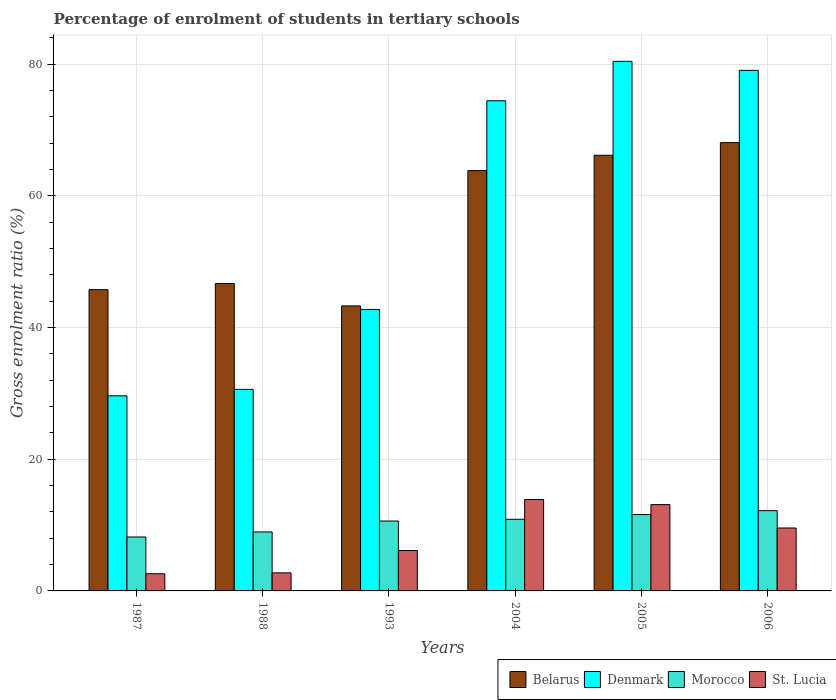How many groups of bars are there?
Offer a very short reply. 6. Are the number of bars on each tick of the X-axis equal?
Your answer should be compact. Yes. How many bars are there on the 2nd tick from the right?
Offer a terse response. 4. What is the label of the 4th group of bars from the left?
Provide a succinct answer. 2004. In how many cases, is the number of bars for a given year not equal to the number of legend labels?
Offer a very short reply. 0. What is the percentage of students enrolled in tertiary schools in Morocco in 1993?
Offer a terse response. 10.62. Across all years, what is the maximum percentage of students enrolled in tertiary schools in Belarus?
Offer a very short reply. 68.09. Across all years, what is the minimum percentage of students enrolled in tertiary schools in St. Lucia?
Keep it short and to the point. 2.61. In which year was the percentage of students enrolled in tertiary schools in Morocco maximum?
Give a very brief answer. 2006. What is the total percentage of students enrolled in tertiary schools in Denmark in the graph?
Give a very brief answer. 336.93. What is the difference between the percentage of students enrolled in tertiary schools in Belarus in 1987 and that in 2006?
Your response must be concise. -22.33. What is the difference between the percentage of students enrolled in tertiary schools in Belarus in 1987 and the percentage of students enrolled in tertiary schools in Denmark in 2004?
Your answer should be very brief. -28.69. What is the average percentage of students enrolled in tertiary schools in Denmark per year?
Keep it short and to the point. 56.15. In the year 2004, what is the difference between the percentage of students enrolled in tertiary schools in Denmark and percentage of students enrolled in tertiary schools in Belarus?
Ensure brevity in your answer.  10.61. What is the ratio of the percentage of students enrolled in tertiary schools in Denmark in 1988 to that in 2004?
Make the answer very short. 0.41. What is the difference between the highest and the second highest percentage of students enrolled in tertiary schools in Morocco?
Keep it short and to the point. 0.6. What is the difference between the highest and the lowest percentage of students enrolled in tertiary schools in Morocco?
Offer a very short reply. 4. Is it the case that in every year, the sum of the percentage of students enrolled in tertiary schools in Denmark and percentage of students enrolled in tertiary schools in St. Lucia is greater than the sum of percentage of students enrolled in tertiary schools in Morocco and percentage of students enrolled in tertiary schools in Belarus?
Provide a succinct answer. No. What does the 2nd bar from the right in 1993 represents?
Your answer should be compact. Morocco. Is it the case that in every year, the sum of the percentage of students enrolled in tertiary schools in Denmark and percentage of students enrolled in tertiary schools in Belarus is greater than the percentage of students enrolled in tertiary schools in St. Lucia?
Your response must be concise. Yes. How many bars are there?
Offer a terse response. 24. Are all the bars in the graph horizontal?
Offer a very short reply. No. How are the legend labels stacked?
Offer a very short reply. Horizontal. What is the title of the graph?
Ensure brevity in your answer.  Percentage of enrolment of students in tertiary schools. What is the label or title of the X-axis?
Offer a very short reply. Years. What is the Gross enrolment ratio (%) of Belarus in 1987?
Provide a succinct answer. 45.76. What is the Gross enrolment ratio (%) of Denmark in 1987?
Keep it short and to the point. 29.63. What is the Gross enrolment ratio (%) in Morocco in 1987?
Keep it short and to the point. 8.19. What is the Gross enrolment ratio (%) in St. Lucia in 1987?
Ensure brevity in your answer.  2.61. What is the Gross enrolment ratio (%) in Belarus in 1988?
Your answer should be very brief. 46.69. What is the Gross enrolment ratio (%) in Denmark in 1988?
Provide a short and direct response. 30.61. What is the Gross enrolment ratio (%) of Morocco in 1988?
Offer a terse response. 8.96. What is the Gross enrolment ratio (%) of St. Lucia in 1988?
Offer a very short reply. 2.74. What is the Gross enrolment ratio (%) in Belarus in 1993?
Ensure brevity in your answer.  43.29. What is the Gross enrolment ratio (%) of Denmark in 1993?
Ensure brevity in your answer.  42.75. What is the Gross enrolment ratio (%) in Morocco in 1993?
Ensure brevity in your answer.  10.62. What is the Gross enrolment ratio (%) in St. Lucia in 1993?
Your answer should be compact. 6.13. What is the Gross enrolment ratio (%) in Belarus in 2004?
Your response must be concise. 63.84. What is the Gross enrolment ratio (%) of Denmark in 2004?
Provide a succinct answer. 74.44. What is the Gross enrolment ratio (%) of Morocco in 2004?
Offer a very short reply. 10.88. What is the Gross enrolment ratio (%) in St. Lucia in 2004?
Offer a terse response. 13.88. What is the Gross enrolment ratio (%) of Belarus in 2005?
Provide a short and direct response. 66.17. What is the Gross enrolment ratio (%) of Denmark in 2005?
Your answer should be compact. 80.43. What is the Gross enrolment ratio (%) of Morocco in 2005?
Keep it short and to the point. 11.6. What is the Gross enrolment ratio (%) in St. Lucia in 2005?
Provide a short and direct response. 13.11. What is the Gross enrolment ratio (%) of Belarus in 2006?
Keep it short and to the point. 68.09. What is the Gross enrolment ratio (%) of Denmark in 2006?
Offer a terse response. 79.06. What is the Gross enrolment ratio (%) of Morocco in 2006?
Your answer should be very brief. 12.19. What is the Gross enrolment ratio (%) in St. Lucia in 2006?
Offer a terse response. 9.56. Across all years, what is the maximum Gross enrolment ratio (%) of Belarus?
Your response must be concise. 68.09. Across all years, what is the maximum Gross enrolment ratio (%) of Denmark?
Your response must be concise. 80.43. Across all years, what is the maximum Gross enrolment ratio (%) of Morocco?
Offer a terse response. 12.19. Across all years, what is the maximum Gross enrolment ratio (%) in St. Lucia?
Provide a succinct answer. 13.88. Across all years, what is the minimum Gross enrolment ratio (%) of Belarus?
Ensure brevity in your answer.  43.29. Across all years, what is the minimum Gross enrolment ratio (%) in Denmark?
Keep it short and to the point. 29.63. Across all years, what is the minimum Gross enrolment ratio (%) in Morocco?
Provide a short and direct response. 8.19. Across all years, what is the minimum Gross enrolment ratio (%) in St. Lucia?
Your answer should be very brief. 2.61. What is the total Gross enrolment ratio (%) in Belarus in the graph?
Your answer should be compact. 333.83. What is the total Gross enrolment ratio (%) in Denmark in the graph?
Offer a very short reply. 336.93. What is the total Gross enrolment ratio (%) of Morocco in the graph?
Provide a succinct answer. 62.44. What is the total Gross enrolment ratio (%) in St. Lucia in the graph?
Provide a succinct answer. 48.04. What is the difference between the Gross enrolment ratio (%) of Belarus in 1987 and that in 1988?
Offer a very short reply. -0.94. What is the difference between the Gross enrolment ratio (%) in Denmark in 1987 and that in 1988?
Ensure brevity in your answer.  -0.98. What is the difference between the Gross enrolment ratio (%) in Morocco in 1987 and that in 1988?
Offer a very short reply. -0.77. What is the difference between the Gross enrolment ratio (%) in St. Lucia in 1987 and that in 1988?
Your answer should be compact. -0.13. What is the difference between the Gross enrolment ratio (%) in Belarus in 1987 and that in 1993?
Your answer should be compact. 2.47. What is the difference between the Gross enrolment ratio (%) of Denmark in 1987 and that in 1993?
Your answer should be compact. -13.12. What is the difference between the Gross enrolment ratio (%) of Morocco in 1987 and that in 1993?
Your response must be concise. -2.43. What is the difference between the Gross enrolment ratio (%) in St. Lucia in 1987 and that in 1993?
Provide a succinct answer. -3.52. What is the difference between the Gross enrolment ratio (%) of Belarus in 1987 and that in 2004?
Offer a terse response. -18.08. What is the difference between the Gross enrolment ratio (%) of Denmark in 1987 and that in 2004?
Offer a terse response. -44.81. What is the difference between the Gross enrolment ratio (%) in Morocco in 1987 and that in 2004?
Offer a terse response. -2.69. What is the difference between the Gross enrolment ratio (%) of St. Lucia in 1987 and that in 2004?
Make the answer very short. -11.27. What is the difference between the Gross enrolment ratio (%) in Belarus in 1987 and that in 2005?
Your answer should be compact. -20.41. What is the difference between the Gross enrolment ratio (%) of Denmark in 1987 and that in 2005?
Provide a succinct answer. -50.8. What is the difference between the Gross enrolment ratio (%) of Morocco in 1987 and that in 2005?
Ensure brevity in your answer.  -3.41. What is the difference between the Gross enrolment ratio (%) in St. Lucia in 1987 and that in 2005?
Your response must be concise. -10.5. What is the difference between the Gross enrolment ratio (%) of Belarus in 1987 and that in 2006?
Provide a short and direct response. -22.33. What is the difference between the Gross enrolment ratio (%) in Denmark in 1987 and that in 2006?
Provide a short and direct response. -49.43. What is the difference between the Gross enrolment ratio (%) of Morocco in 1987 and that in 2006?
Offer a very short reply. -4. What is the difference between the Gross enrolment ratio (%) of St. Lucia in 1987 and that in 2006?
Make the answer very short. -6.95. What is the difference between the Gross enrolment ratio (%) of Belarus in 1988 and that in 1993?
Provide a succinct answer. 3.41. What is the difference between the Gross enrolment ratio (%) in Denmark in 1988 and that in 1993?
Offer a terse response. -12.14. What is the difference between the Gross enrolment ratio (%) in Morocco in 1988 and that in 1993?
Give a very brief answer. -1.66. What is the difference between the Gross enrolment ratio (%) of St. Lucia in 1988 and that in 1993?
Offer a very short reply. -3.39. What is the difference between the Gross enrolment ratio (%) in Belarus in 1988 and that in 2004?
Your answer should be very brief. -17.14. What is the difference between the Gross enrolment ratio (%) of Denmark in 1988 and that in 2004?
Offer a terse response. -43.83. What is the difference between the Gross enrolment ratio (%) of Morocco in 1988 and that in 2004?
Give a very brief answer. -1.92. What is the difference between the Gross enrolment ratio (%) of St. Lucia in 1988 and that in 2004?
Keep it short and to the point. -11.14. What is the difference between the Gross enrolment ratio (%) of Belarus in 1988 and that in 2005?
Ensure brevity in your answer.  -19.48. What is the difference between the Gross enrolment ratio (%) of Denmark in 1988 and that in 2005?
Offer a very short reply. -49.82. What is the difference between the Gross enrolment ratio (%) in Morocco in 1988 and that in 2005?
Your response must be concise. -2.64. What is the difference between the Gross enrolment ratio (%) in St. Lucia in 1988 and that in 2005?
Provide a succinct answer. -10.36. What is the difference between the Gross enrolment ratio (%) in Belarus in 1988 and that in 2006?
Your answer should be compact. -21.39. What is the difference between the Gross enrolment ratio (%) in Denmark in 1988 and that in 2006?
Provide a short and direct response. -48.45. What is the difference between the Gross enrolment ratio (%) of Morocco in 1988 and that in 2006?
Make the answer very short. -3.24. What is the difference between the Gross enrolment ratio (%) in St. Lucia in 1988 and that in 2006?
Keep it short and to the point. -6.81. What is the difference between the Gross enrolment ratio (%) of Belarus in 1993 and that in 2004?
Make the answer very short. -20.55. What is the difference between the Gross enrolment ratio (%) of Denmark in 1993 and that in 2004?
Keep it short and to the point. -31.69. What is the difference between the Gross enrolment ratio (%) of Morocco in 1993 and that in 2004?
Your answer should be compact. -0.26. What is the difference between the Gross enrolment ratio (%) in St. Lucia in 1993 and that in 2004?
Offer a very short reply. -7.75. What is the difference between the Gross enrolment ratio (%) in Belarus in 1993 and that in 2005?
Your response must be concise. -22.88. What is the difference between the Gross enrolment ratio (%) in Denmark in 1993 and that in 2005?
Provide a short and direct response. -37.68. What is the difference between the Gross enrolment ratio (%) of Morocco in 1993 and that in 2005?
Ensure brevity in your answer.  -0.98. What is the difference between the Gross enrolment ratio (%) in St. Lucia in 1993 and that in 2005?
Provide a succinct answer. -6.97. What is the difference between the Gross enrolment ratio (%) of Belarus in 1993 and that in 2006?
Your answer should be compact. -24.8. What is the difference between the Gross enrolment ratio (%) in Denmark in 1993 and that in 2006?
Provide a short and direct response. -36.32. What is the difference between the Gross enrolment ratio (%) in Morocco in 1993 and that in 2006?
Your answer should be very brief. -1.58. What is the difference between the Gross enrolment ratio (%) in St. Lucia in 1993 and that in 2006?
Give a very brief answer. -3.42. What is the difference between the Gross enrolment ratio (%) of Belarus in 2004 and that in 2005?
Your answer should be compact. -2.33. What is the difference between the Gross enrolment ratio (%) in Denmark in 2004 and that in 2005?
Keep it short and to the point. -5.99. What is the difference between the Gross enrolment ratio (%) of Morocco in 2004 and that in 2005?
Offer a very short reply. -0.72. What is the difference between the Gross enrolment ratio (%) in St. Lucia in 2004 and that in 2005?
Ensure brevity in your answer.  0.78. What is the difference between the Gross enrolment ratio (%) of Belarus in 2004 and that in 2006?
Provide a short and direct response. -4.25. What is the difference between the Gross enrolment ratio (%) in Denmark in 2004 and that in 2006?
Give a very brief answer. -4.62. What is the difference between the Gross enrolment ratio (%) of Morocco in 2004 and that in 2006?
Provide a succinct answer. -1.31. What is the difference between the Gross enrolment ratio (%) of St. Lucia in 2004 and that in 2006?
Provide a short and direct response. 4.32. What is the difference between the Gross enrolment ratio (%) of Belarus in 2005 and that in 2006?
Your answer should be very brief. -1.92. What is the difference between the Gross enrolment ratio (%) of Denmark in 2005 and that in 2006?
Provide a succinct answer. 1.36. What is the difference between the Gross enrolment ratio (%) of Morocco in 2005 and that in 2006?
Your answer should be very brief. -0.6. What is the difference between the Gross enrolment ratio (%) in St. Lucia in 2005 and that in 2006?
Give a very brief answer. 3.55. What is the difference between the Gross enrolment ratio (%) of Belarus in 1987 and the Gross enrolment ratio (%) of Denmark in 1988?
Offer a very short reply. 15.14. What is the difference between the Gross enrolment ratio (%) of Belarus in 1987 and the Gross enrolment ratio (%) of Morocco in 1988?
Keep it short and to the point. 36.8. What is the difference between the Gross enrolment ratio (%) of Belarus in 1987 and the Gross enrolment ratio (%) of St. Lucia in 1988?
Offer a very short reply. 43.01. What is the difference between the Gross enrolment ratio (%) in Denmark in 1987 and the Gross enrolment ratio (%) in Morocco in 1988?
Provide a short and direct response. 20.67. What is the difference between the Gross enrolment ratio (%) of Denmark in 1987 and the Gross enrolment ratio (%) of St. Lucia in 1988?
Provide a short and direct response. 26.89. What is the difference between the Gross enrolment ratio (%) of Morocco in 1987 and the Gross enrolment ratio (%) of St. Lucia in 1988?
Offer a terse response. 5.45. What is the difference between the Gross enrolment ratio (%) of Belarus in 1987 and the Gross enrolment ratio (%) of Denmark in 1993?
Provide a succinct answer. 3.01. What is the difference between the Gross enrolment ratio (%) in Belarus in 1987 and the Gross enrolment ratio (%) in Morocco in 1993?
Your answer should be very brief. 35.14. What is the difference between the Gross enrolment ratio (%) in Belarus in 1987 and the Gross enrolment ratio (%) in St. Lucia in 1993?
Provide a short and direct response. 39.62. What is the difference between the Gross enrolment ratio (%) in Denmark in 1987 and the Gross enrolment ratio (%) in Morocco in 1993?
Your answer should be very brief. 19.02. What is the difference between the Gross enrolment ratio (%) of Denmark in 1987 and the Gross enrolment ratio (%) of St. Lucia in 1993?
Offer a very short reply. 23.5. What is the difference between the Gross enrolment ratio (%) of Morocco in 1987 and the Gross enrolment ratio (%) of St. Lucia in 1993?
Your answer should be compact. 2.06. What is the difference between the Gross enrolment ratio (%) of Belarus in 1987 and the Gross enrolment ratio (%) of Denmark in 2004?
Make the answer very short. -28.69. What is the difference between the Gross enrolment ratio (%) of Belarus in 1987 and the Gross enrolment ratio (%) of Morocco in 2004?
Keep it short and to the point. 34.88. What is the difference between the Gross enrolment ratio (%) in Belarus in 1987 and the Gross enrolment ratio (%) in St. Lucia in 2004?
Offer a terse response. 31.87. What is the difference between the Gross enrolment ratio (%) in Denmark in 1987 and the Gross enrolment ratio (%) in Morocco in 2004?
Your response must be concise. 18.75. What is the difference between the Gross enrolment ratio (%) in Denmark in 1987 and the Gross enrolment ratio (%) in St. Lucia in 2004?
Ensure brevity in your answer.  15.75. What is the difference between the Gross enrolment ratio (%) of Morocco in 1987 and the Gross enrolment ratio (%) of St. Lucia in 2004?
Ensure brevity in your answer.  -5.69. What is the difference between the Gross enrolment ratio (%) of Belarus in 1987 and the Gross enrolment ratio (%) of Denmark in 2005?
Provide a succinct answer. -34.67. What is the difference between the Gross enrolment ratio (%) in Belarus in 1987 and the Gross enrolment ratio (%) in Morocco in 2005?
Your answer should be very brief. 34.16. What is the difference between the Gross enrolment ratio (%) in Belarus in 1987 and the Gross enrolment ratio (%) in St. Lucia in 2005?
Your answer should be very brief. 32.65. What is the difference between the Gross enrolment ratio (%) of Denmark in 1987 and the Gross enrolment ratio (%) of Morocco in 2005?
Keep it short and to the point. 18.03. What is the difference between the Gross enrolment ratio (%) of Denmark in 1987 and the Gross enrolment ratio (%) of St. Lucia in 2005?
Offer a very short reply. 16.52. What is the difference between the Gross enrolment ratio (%) of Morocco in 1987 and the Gross enrolment ratio (%) of St. Lucia in 2005?
Your response must be concise. -4.92. What is the difference between the Gross enrolment ratio (%) in Belarus in 1987 and the Gross enrolment ratio (%) in Denmark in 2006?
Provide a succinct answer. -33.31. What is the difference between the Gross enrolment ratio (%) of Belarus in 1987 and the Gross enrolment ratio (%) of Morocco in 2006?
Your response must be concise. 33.56. What is the difference between the Gross enrolment ratio (%) in Belarus in 1987 and the Gross enrolment ratio (%) in St. Lucia in 2006?
Ensure brevity in your answer.  36.2. What is the difference between the Gross enrolment ratio (%) of Denmark in 1987 and the Gross enrolment ratio (%) of Morocco in 2006?
Offer a very short reply. 17.44. What is the difference between the Gross enrolment ratio (%) of Denmark in 1987 and the Gross enrolment ratio (%) of St. Lucia in 2006?
Ensure brevity in your answer.  20.07. What is the difference between the Gross enrolment ratio (%) in Morocco in 1987 and the Gross enrolment ratio (%) in St. Lucia in 2006?
Give a very brief answer. -1.37. What is the difference between the Gross enrolment ratio (%) of Belarus in 1988 and the Gross enrolment ratio (%) of Denmark in 1993?
Provide a short and direct response. 3.95. What is the difference between the Gross enrolment ratio (%) in Belarus in 1988 and the Gross enrolment ratio (%) in Morocco in 1993?
Your answer should be compact. 36.08. What is the difference between the Gross enrolment ratio (%) in Belarus in 1988 and the Gross enrolment ratio (%) in St. Lucia in 1993?
Your answer should be very brief. 40.56. What is the difference between the Gross enrolment ratio (%) in Denmark in 1988 and the Gross enrolment ratio (%) in Morocco in 1993?
Your answer should be very brief. 20. What is the difference between the Gross enrolment ratio (%) of Denmark in 1988 and the Gross enrolment ratio (%) of St. Lucia in 1993?
Offer a very short reply. 24.48. What is the difference between the Gross enrolment ratio (%) in Morocco in 1988 and the Gross enrolment ratio (%) in St. Lucia in 1993?
Provide a succinct answer. 2.82. What is the difference between the Gross enrolment ratio (%) of Belarus in 1988 and the Gross enrolment ratio (%) of Denmark in 2004?
Ensure brevity in your answer.  -27.75. What is the difference between the Gross enrolment ratio (%) of Belarus in 1988 and the Gross enrolment ratio (%) of Morocco in 2004?
Provide a succinct answer. 35.81. What is the difference between the Gross enrolment ratio (%) in Belarus in 1988 and the Gross enrolment ratio (%) in St. Lucia in 2004?
Ensure brevity in your answer.  32.81. What is the difference between the Gross enrolment ratio (%) of Denmark in 1988 and the Gross enrolment ratio (%) of Morocco in 2004?
Give a very brief answer. 19.73. What is the difference between the Gross enrolment ratio (%) in Denmark in 1988 and the Gross enrolment ratio (%) in St. Lucia in 2004?
Your answer should be very brief. 16.73. What is the difference between the Gross enrolment ratio (%) in Morocco in 1988 and the Gross enrolment ratio (%) in St. Lucia in 2004?
Provide a short and direct response. -4.93. What is the difference between the Gross enrolment ratio (%) in Belarus in 1988 and the Gross enrolment ratio (%) in Denmark in 2005?
Your answer should be compact. -33.74. What is the difference between the Gross enrolment ratio (%) of Belarus in 1988 and the Gross enrolment ratio (%) of Morocco in 2005?
Keep it short and to the point. 35.09. What is the difference between the Gross enrolment ratio (%) of Belarus in 1988 and the Gross enrolment ratio (%) of St. Lucia in 2005?
Your answer should be very brief. 33.59. What is the difference between the Gross enrolment ratio (%) in Denmark in 1988 and the Gross enrolment ratio (%) in Morocco in 2005?
Make the answer very short. 19.01. What is the difference between the Gross enrolment ratio (%) in Denmark in 1988 and the Gross enrolment ratio (%) in St. Lucia in 2005?
Offer a very short reply. 17.51. What is the difference between the Gross enrolment ratio (%) of Morocco in 1988 and the Gross enrolment ratio (%) of St. Lucia in 2005?
Give a very brief answer. -4.15. What is the difference between the Gross enrolment ratio (%) of Belarus in 1988 and the Gross enrolment ratio (%) of Denmark in 2006?
Make the answer very short. -32.37. What is the difference between the Gross enrolment ratio (%) of Belarus in 1988 and the Gross enrolment ratio (%) of Morocco in 2006?
Your answer should be very brief. 34.5. What is the difference between the Gross enrolment ratio (%) of Belarus in 1988 and the Gross enrolment ratio (%) of St. Lucia in 2006?
Your answer should be very brief. 37.13. What is the difference between the Gross enrolment ratio (%) in Denmark in 1988 and the Gross enrolment ratio (%) in Morocco in 2006?
Offer a very short reply. 18.42. What is the difference between the Gross enrolment ratio (%) of Denmark in 1988 and the Gross enrolment ratio (%) of St. Lucia in 2006?
Your answer should be very brief. 21.05. What is the difference between the Gross enrolment ratio (%) in Morocco in 1988 and the Gross enrolment ratio (%) in St. Lucia in 2006?
Offer a terse response. -0.6. What is the difference between the Gross enrolment ratio (%) in Belarus in 1993 and the Gross enrolment ratio (%) in Denmark in 2004?
Keep it short and to the point. -31.15. What is the difference between the Gross enrolment ratio (%) in Belarus in 1993 and the Gross enrolment ratio (%) in Morocco in 2004?
Your response must be concise. 32.41. What is the difference between the Gross enrolment ratio (%) of Belarus in 1993 and the Gross enrolment ratio (%) of St. Lucia in 2004?
Ensure brevity in your answer.  29.4. What is the difference between the Gross enrolment ratio (%) of Denmark in 1993 and the Gross enrolment ratio (%) of Morocco in 2004?
Give a very brief answer. 31.87. What is the difference between the Gross enrolment ratio (%) in Denmark in 1993 and the Gross enrolment ratio (%) in St. Lucia in 2004?
Provide a short and direct response. 28.86. What is the difference between the Gross enrolment ratio (%) in Morocco in 1993 and the Gross enrolment ratio (%) in St. Lucia in 2004?
Give a very brief answer. -3.27. What is the difference between the Gross enrolment ratio (%) of Belarus in 1993 and the Gross enrolment ratio (%) of Denmark in 2005?
Provide a succinct answer. -37.14. What is the difference between the Gross enrolment ratio (%) in Belarus in 1993 and the Gross enrolment ratio (%) in Morocco in 2005?
Ensure brevity in your answer.  31.69. What is the difference between the Gross enrolment ratio (%) of Belarus in 1993 and the Gross enrolment ratio (%) of St. Lucia in 2005?
Offer a terse response. 30.18. What is the difference between the Gross enrolment ratio (%) of Denmark in 1993 and the Gross enrolment ratio (%) of Morocco in 2005?
Keep it short and to the point. 31.15. What is the difference between the Gross enrolment ratio (%) in Denmark in 1993 and the Gross enrolment ratio (%) in St. Lucia in 2005?
Offer a very short reply. 29.64. What is the difference between the Gross enrolment ratio (%) in Morocco in 1993 and the Gross enrolment ratio (%) in St. Lucia in 2005?
Your answer should be compact. -2.49. What is the difference between the Gross enrolment ratio (%) in Belarus in 1993 and the Gross enrolment ratio (%) in Denmark in 2006?
Offer a terse response. -35.78. What is the difference between the Gross enrolment ratio (%) of Belarus in 1993 and the Gross enrolment ratio (%) of Morocco in 2006?
Ensure brevity in your answer.  31.09. What is the difference between the Gross enrolment ratio (%) of Belarus in 1993 and the Gross enrolment ratio (%) of St. Lucia in 2006?
Your answer should be compact. 33.73. What is the difference between the Gross enrolment ratio (%) of Denmark in 1993 and the Gross enrolment ratio (%) of Morocco in 2006?
Ensure brevity in your answer.  30.55. What is the difference between the Gross enrolment ratio (%) in Denmark in 1993 and the Gross enrolment ratio (%) in St. Lucia in 2006?
Ensure brevity in your answer.  33.19. What is the difference between the Gross enrolment ratio (%) in Morocco in 1993 and the Gross enrolment ratio (%) in St. Lucia in 2006?
Keep it short and to the point. 1.06. What is the difference between the Gross enrolment ratio (%) of Belarus in 2004 and the Gross enrolment ratio (%) of Denmark in 2005?
Your response must be concise. -16.59. What is the difference between the Gross enrolment ratio (%) of Belarus in 2004 and the Gross enrolment ratio (%) of Morocco in 2005?
Your answer should be very brief. 52.24. What is the difference between the Gross enrolment ratio (%) in Belarus in 2004 and the Gross enrolment ratio (%) in St. Lucia in 2005?
Offer a terse response. 50.73. What is the difference between the Gross enrolment ratio (%) of Denmark in 2004 and the Gross enrolment ratio (%) of Morocco in 2005?
Your response must be concise. 62.84. What is the difference between the Gross enrolment ratio (%) in Denmark in 2004 and the Gross enrolment ratio (%) in St. Lucia in 2005?
Your response must be concise. 61.34. What is the difference between the Gross enrolment ratio (%) in Morocco in 2004 and the Gross enrolment ratio (%) in St. Lucia in 2005?
Give a very brief answer. -2.23. What is the difference between the Gross enrolment ratio (%) of Belarus in 2004 and the Gross enrolment ratio (%) of Denmark in 2006?
Make the answer very short. -15.23. What is the difference between the Gross enrolment ratio (%) of Belarus in 2004 and the Gross enrolment ratio (%) of Morocco in 2006?
Your response must be concise. 51.64. What is the difference between the Gross enrolment ratio (%) in Belarus in 2004 and the Gross enrolment ratio (%) in St. Lucia in 2006?
Make the answer very short. 54.28. What is the difference between the Gross enrolment ratio (%) of Denmark in 2004 and the Gross enrolment ratio (%) of Morocco in 2006?
Your response must be concise. 62.25. What is the difference between the Gross enrolment ratio (%) in Denmark in 2004 and the Gross enrolment ratio (%) in St. Lucia in 2006?
Ensure brevity in your answer.  64.88. What is the difference between the Gross enrolment ratio (%) in Morocco in 2004 and the Gross enrolment ratio (%) in St. Lucia in 2006?
Your response must be concise. 1.32. What is the difference between the Gross enrolment ratio (%) of Belarus in 2005 and the Gross enrolment ratio (%) of Denmark in 2006?
Keep it short and to the point. -12.9. What is the difference between the Gross enrolment ratio (%) in Belarus in 2005 and the Gross enrolment ratio (%) in Morocco in 2006?
Offer a terse response. 53.97. What is the difference between the Gross enrolment ratio (%) of Belarus in 2005 and the Gross enrolment ratio (%) of St. Lucia in 2006?
Offer a terse response. 56.61. What is the difference between the Gross enrolment ratio (%) in Denmark in 2005 and the Gross enrolment ratio (%) in Morocco in 2006?
Provide a succinct answer. 68.23. What is the difference between the Gross enrolment ratio (%) in Denmark in 2005 and the Gross enrolment ratio (%) in St. Lucia in 2006?
Provide a short and direct response. 70.87. What is the difference between the Gross enrolment ratio (%) of Morocco in 2005 and the Gross enrolment ratio (%) of St. Lucia in 2006?
Provide a short and direct response. 2.04. What is the average Gross enrolment ratio (%) of Belarus per year?
Make the answer very short. 55.64. What is the average Gross enrolment ratio (%) in Denmark per year?
Your answer should be compact. 56.15. What is the average Gross enrolment ratio (%) in Morocco per year?
Your answer should be very brief. 10.41. What is the average Gross enrolment ratio (%) in St. Lucia per year?
Provide a succinct answer. 8.01. In the year 1987, what is the difference between the Gross enrolment ratio (%) in Belarus and Gross enrolment ratio (%) in Denmark?
Give a very brief answer. 16.12. In the year 1987, what is the difference between the Gross enrolment ratio (%) in Belarus and Gross enrolment ratio (%) in Morocco?
Make the answer very short. 37.57. In the year 1987, what is the difference between the Gross enrolment ratio (%) in Belarus and Gross enrolment ratio (%) in St. Lucia?
Your answer should be very brief. 43.15. In the year 1987, what is the difference between the Gross enrolment ratio (%) in Denmark and Gross enrolment ratio (%) in Morocco?
Ensure brevity in your answer.  21.44. In the year 1987, what is the difference between the Gross enrolment ratio (%) of Denmark and Gross enrolment ratio (%) of St. Lucia?
Offer a terse response. 27.02. In the year 1987, what is the difference between the Gross enrolment ratio (%) of Morocco and Gross enrolment ratio (%) of St. Lucia?
Your answer should be compact. 5.58. In the year 1988, what is the difference between the Gross enrolment ratio (%) in Belarus and Gross enrolment ratio (%) in Denmark?
Give a very brief answer. 16.08. In the year 1988, what is the difference between the Gross enrolment ratio (%) of Belarus and Gross enrolment ratio (%) of Morocco?
Provide a short and direct response. 37.74. In the year 1988, what is the difference between the Gross enrolment ratio (%) of Belarus and Gross enrolment ratio (%) of St. Lucia?
Provide a short and direct response. 43.95. In the year 1988, what is the difference between the Gross enrolment ratio (%) of Denmark and Gross enrolment ratio (%) of Morocco?
Make the answer very short. 21.66. In the year 1988, what is the difference between the Gross enrolment ratio (%) in Denmark and Gross enrolment ratio (%) in St. Lucia?
Offer a very short reply. 27.87. In the year 1988, what is the difference between the Gross enrolment ratio (%) in Morocco and Gross enrolment ratio (%) in St. Lucia?
Offer a very short reply. 6.21. In the year 1993, what is the difference between the Gross enrolment ratio (%) of Belarus and Gross enrolment ratio (%) of Denmark?
Your answer should be very brief. 0.54. In the year 1993, what is the difference between the Gross enrolment ratio (%) in Belarus and Gross enrolment ratio (%) in Morocco?
Give a very brief answer. 32.67. In the year 1993, what is the difference between the Gross enrolment ratio (%) of Belarus and Gross enrolment ratio (%) of St. Lucia?
Ensure brevity in your answer.  37.15. In the year 1993, what is the difference between the Gross enrolment ratio (%) of Denmark and Gross enrolment ratio (%) of Morocco?
Your response must be concise. 32.13. In the year 1993, what is the difference between the Gross enrolment ratio (%) in Denmark and Gross enrolment ratio (%) in St. Lucia?
Provide a short and direct response. 36.61. In the year 1993, what is the difference between the Gross enrolment ratio (%) of Morocco and Gross enrolment ratio (%) of St. Lucia?
Provide a short and direct response. 4.48. In the year 2004, what is the difference between the Gross enrolment ratio (%) in Belarus and Gross enrolment ratio (%) in Denmark?
Keep it short and to the point. -10.61. In the year 2004, what is the difference between the Gross enrolment ratio (%) of Belarus and Gross enrolment ratio (%) of Morocco?
Your answer should be very brief. 52.96. In the year 2004, what is the difference between the Gross enrolment ratio (%) in Belarus and Gross enrolment ratio (%) in St. Lucia?
Your answer should be very brief. 49.95. In the year 2004, what is the difference between the Gross enrolment ratio (%) in Denmark and Gross enrolment ratio (%) in Morocco?
Your response must be concise. 63.56. In the year 2004, what is the difference between the Gross enrolment ratio (%) of Denmark and Gross enrolment ratio (%) of St. Lucia?
Your answer should be compact. 60.56. In the year 2004, what is the difference between the Gross enrolment ratio (%) in Morocco and Gross enrolment ratio (%) in St. Lucia?
Your answer should be very brief. -3. In the year 2005, what is the difference between the Gross enrolment ratio (%) of Belarus and Gross enrolment ratio (%) of Denmark?
Make the answer very short. -14.26. In the year 2005, what is the difference between the Gross enrolment ratio (%) of Belarus and Gross enrolment ratio (%) of Morocco?
Offer a very short reply. 54.57. In the year 2005, what is the difference between the Gross enrolment ratio (%) in Belarus and Gross enrolment ratio (%) in St. Lucia?
Provide a succinct answer. 53.06. In the year 2005, what is the difference between the Gross enrolment ratio (%) of Denmark and Gross enrolment ratio (%) of Morocco?
Give a very brief answer. 68.83. In the year 2005, what is the difference between the Gross enrolment ratio (%) in Denmark and Gross enrolment ratio (%) in St. Lucia?
Make the answer very short. 67.32. In the year 2005, what is the difference between the Gross enrolment ratio (%) of Morocco and Gross enrolment ratio (%) of St. Lucia?
Offer a very short reply. -1.51. In the year 2006, what is the difference between the Gross enrolment ratio (%) in Belarus and Gross enrolment ratio (%) in Denmark?
Offer a terse response. -10.98. In the year 2006, what is the difference between the Gross enrolment ratio (%) of Belarus and Gross enrolment ratio (%) of Morocco?
Make the answer very short. 55.89. In the year 2006, what is the difference between the Gross enrolment ratio (%) of Belarus and Gross enrolment ratio (%) of St. Lucia?
Offer a terse response. 58.53. In the year 2006, what is the difference between the Gross enrolment ratio (%) in Denmark and Gross enrolment ratio (%) in Morocco?
Offer a terse response. 66.87. In the year 2006, what is the difference between the Gross enrolment ratio (%) of Denmark and Gross enrolment ratio (%) of St. Lucia?
Your answer should be compact. 69.51. In the year 2006, what is the difference between the Gross enrolment ratio (%) of Morocco and Gross enrolment ratio (%) of St. Lucia?
Keep it short and to the point. 2.64. What is the ratio of the Gross enrolment ratio (%) in Belarus in 1987 to that in 1988?
Provide a short and direct response. 0.98. What is the ratio of the Gross enrolment ratio (%) of Morocco in 1987 to that in 1988?
Ensure brevity in your answer.  0.91. What is the ratio of the Gross enrolment ratio (%) in St. Lucia in 1987 to that in 1988?
Provide a short and direct response. 0.95. What is the ratio of the Gross enrolment ratio (%) of Belarus in 1987 to that in 1993?
Your answer should be compact. 1.06. What is the ratio of the Gross enrolment ratio (%) of Denmark in 1987 to that in 1993?
Your answer should be very brief. 0.69. What is the ratio of the Gross enrolment ratio (%) of Morocco in 1987 to that in 1993?
Your answer should be compact. 0.77. What is the ratio of the Gross enrolment ratio (%) of St. Lucia in 1987 to that in 1993?
Provide a succinct answer. 0.43. What is the ratio of the Gross enrolment ratio (%) in Belarus in 1987 to that in 2004?
Ensure brevity in your answer.  0.72. What is the ratio of the Gross enrolment ratio (%) of Denmark in 1987 to that in 2004?
Make the answer very short. 0.4. What is the ratio of the Gross enrolment ratio (%) of Morocco in 1987 to that in 2004?
Provide a succinct answer. 0.75. What is the ratio of the Gross enrolment ratio (%) in St. Lucia in 1987 to that in 2004?
Ensure brevity in your answer.  0.19. What is the ratio of the Gross enrolment ratio (%) of Belarus in 1987 to that in 2005?
Offer a very short reply. 0.69. What is the ratio of the Gross enrolment ratio (%) of Denmark in 1987 to that in 2005?
Make the answer very short. 0.37. What is the ratio of the Gross enrolment ratio (%) in Morocco in 1987 to that in 2005?
Keep it short and to the point. 0.71. What is the ratio of the Gross enrolment ratio (%) of St. Lucia in 1987 to that in 2005?
Make the answer very short. 0.2. What is the ratio of the Gross enrolment ratio (%) in Belarus in 1987 to that in 2006?
Your answer should be very brief. 0.67. What is the ratio of the Gross enrolment ratio (%) of Denmark in 1987 to that in 2006?
Keep it short and to the point. 0.37. What is the ratio of the Gross enrolment ratio (%) in Morocco in 1987 to that in 2006?
Your answer should be very brief. 0.67. What is the ratio of the Gross enrolment ratio (%) of St. Lucia in 1987 to that in 2006?
Your answer should be very brief. 0.27. What is the ratio of the Gross enrolment ratio (%) in Belarus in 1988 to that in 1993?
Your answer should be very brief. 1.08. What is the ratio of the Gross enrolment ratio (%) of Denmark in 1988 to that in 1993?
Offer a very short reply. 0.72. What is the ratio of the Gross enrolment ratio (%) in Morocco in 1988 to that in 1993?
Keep it short and to the point. 0.84. What is the ratio of the Gross enrolment ratio (%) in St. Lucia in 1988 to that in 1993?
Ensure brevity in your answer.  0.45. What is the ratio of the Gross enrolment ratio (%) of Belarus in 1988 to that in 2004?
Offer a terse response. 0.73. What is the ratio of the Gross enrolment ratio (%) of Denmark in 1988 to that in 2004?
Ensure brevity in your answer.  0.41. What is the ratio of the Gross enrolment ratio (%) of Morocco in 1988 to that in 2004?
Ensure brevity in your answer.  0.82. What is the ratio of the Gross enrolment ratio (%) of St. Lucia in 1988 to that in 2004?
Give a very brief answer. 0.2. What is the ratio of the Gross enrolment ratio (%) in Belarus in 1988 to that in 2005?
Your answer should be very brief. 0.71. What is the ratio of the Gross enrolment ratio (%) of Denmark in 1988 to that in 2005?
Offer a terse response. 0.38. What is the ratio of the Gross enrolment ratio (%) in Morocco in 1988 to that in 2005?
Make the answer very short. 0.77. What is the ratio of the Gross enrolment ratio (%) of St. Lucia in 1988 to that in 2005?
Offer a terse response. 0.21. What is the ratio of the Gross enrolment ratio (%) in Belarus in 1988 to that in 2006?
Your answer should be very brief. 0.69. What is the ratio of the Gross enrolment ratio (%) in Denmark in 1988 to that in 2006?
Your answer should be very brief. 0.39. What is the ratio of the Gross enrolment ratio (%) in Morocco in 1988 to that in 2006?
Your answer should be very brief. 0.73. What is the ratio of the Gross enrolment ratio (%) of St. Lucia in 1988 to that in 2006?
Your answer should be very brief. 0.29. What is the ratio of the Gross enrolment ratio (%) of Belarus in 1993 to that in 2004?
Offer a very short reply. 0.68. What is the ratio of the Gross enrolment ratio (%) in Denmark in 1993 to that in 2004?
Provide a short and direct response. 0.57. What is the ratio of the Gross enrolment ratio (%) in Morocco in 1993 to that in 2004?
Your response must be concise. 0.98. What is the ratio of the Gross enrolment ratio (%) of St. Lucia in 1993 to that in 2004?
Offer a terse response. 0.44. What is the ratio of the Gross enrolment ratio (%) of Belarus in 1993 to that in 2005?
Ensure brevity in your answer.  0.65. What is the ratio of the Gross enrolment ratio (%) of Denmark in 1993 to that in 2005?
Offer a terse response. 0.53. What is the ratio of the Gross enrolment ratio (%) of Morocco in 1993 to that in 2005?
Provide a succinct answer. 0.92. What is the ratio of the Gross enrolment ratio (%) in St. Lucia in 1993 to that in 2005?
Ensure brevity in your answer.  0.47. What is the ratio of the Gross enrolment ratio (%) in Belarus in 1993 to that in 2006?
Provide a succinct answer. 0.64. What is the ratio of the Gross enrolment ratio (%) in Denmark in 1993 to that in 2006?
Make the answer very short. 0.54. What is the ratio of the Gross enrolment ratio (%) in Morocco in 1993 to that in 2006?
Keep it short and to the point. 0.87. What is the ratio of the Gross enrolment ratio (%) of St. Lucia in 1993 to that in 2006?
Ensure brevity in your answer.  0.64. What is the ratio of the Gross enrolment ratio (%) of Belarus in 2004 to that in 2005?
Ensure brevity in your answer.  0.96. What is the ratio of the Gross enrolment ratio (%) in Denmark in 2004 to that in 2005?
Your response must be concise. 0.93. What is the ratio of the Gross enrolment ratio (%) of Morocco in 2004 to that in 2005?
Make the answer very short. 0.94. What is the ratio of the Gross enrolment ratio (%) of St. Lucia in 2004 to that in 2005?
Your answer should be compact. 1.06. What is the ratio of the Gross enrolment ratio (%) in Belarus in 2004 to that in 2006?
Provide a succinct answer. 0.94. What is the ratio of the Gross enrolment ratio (%) in Denmark in 2004 to that in 2006?
Offer a very short reply. 0.94. What is the ratio of the Gross enrolment ratio (%) of Morocco in 2004 to that in 2006?
Your answer should be compact. 0.89. What is the ratio of the Gross enrolment ratio (%) of St. Lucia in 2004 to that in 2006?
Offer a terse response. 1.45. What is the ratio of the Gross enrolment ratio (%) in Belarus in 2005 to that in 2006?
Provide a succinct answer. 0.97. What is the ratio of the Gross enrolment ratio (%) of Denmark in 2005 to that in 2006?
Provide a short and direct response. 1.02. What is the ratio of the Gross enrolment ratio (%) in Morocco in 2005 to that in 2006?
Provide a succinct answer. 0.95. What is the ratio of the Gross enrolment ratio (%) of St. Lucia in 2005 to that in 2006?
Your answer should be compact. 1.37. What is the difference between the highest and the second highest Gross enrolment ratio (%) of Belarus?
Your answer should be compact. 1.92. What is the difference between the highest and the second highest Gross enrolment ratio (%) of Denmark?
Ensure brevity in your answer.  1.36. What is the difference between the highest and the second highest Gross enrolment ratio (%) of Morocco?
Give a very brief answer. 0.6. What is the difference between the highest and the second highest Gross enrolment ratio (%) of St. Lucia?
Offer a very short reply. 0.78. What is the difference between the highest and the lowest Gross enrolment ratio (%) of Belarus?
Keep it short and to the point. 24.8. What is the difference between the highest and the lowest Gross enrolment ratio (%) in Denmark?
Give a very brief answer. 50.8. What is the difference between the highest and the lowest Gross enrolment ratio (%) in Morocco?
Your answer should be very brief. 4. What is the difference between the highest and the lowest Gross enrolment ratio (%) of St. Lucia?
Provide a succinct answer. 11.27. 